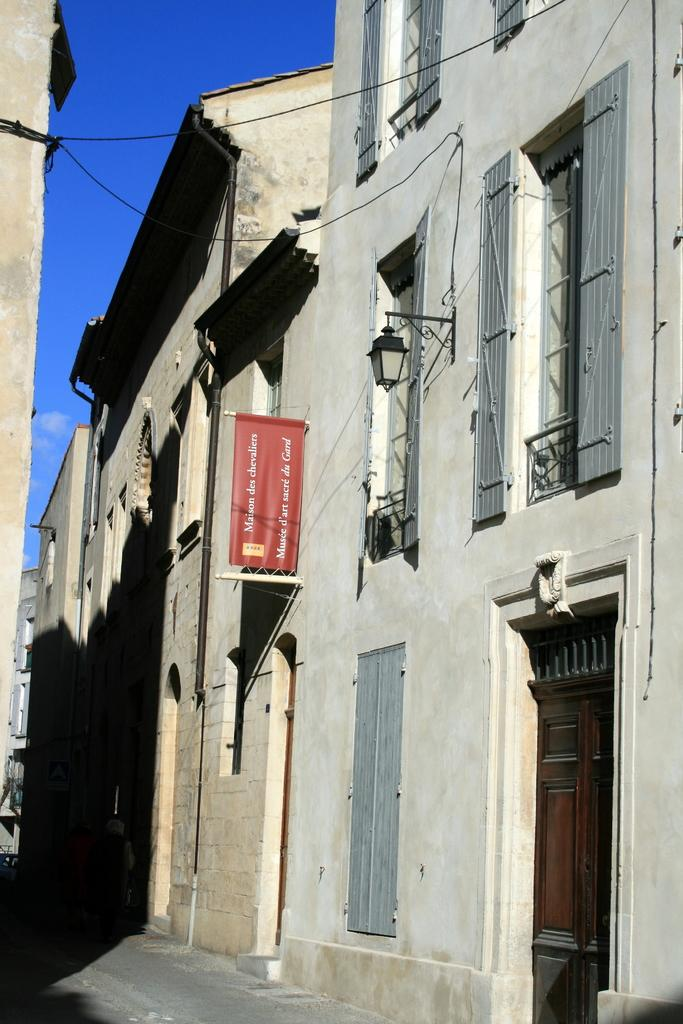What type of structures can be seen in the image? There are buildings in the image. Can you describe any specific features of the image? There is a light and a banner in the image. What is attached to the building? Wires are attached to the building. What can be seen in the background of the image? The sky is visible in the background of the image. What type of lunchroom can be seen in the image? There is no lunchroom present in the image. How long does it take for the turkey to appear in the image? There is no turkey present in the image, so it cannot appear or be timed. 